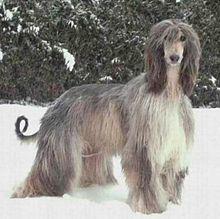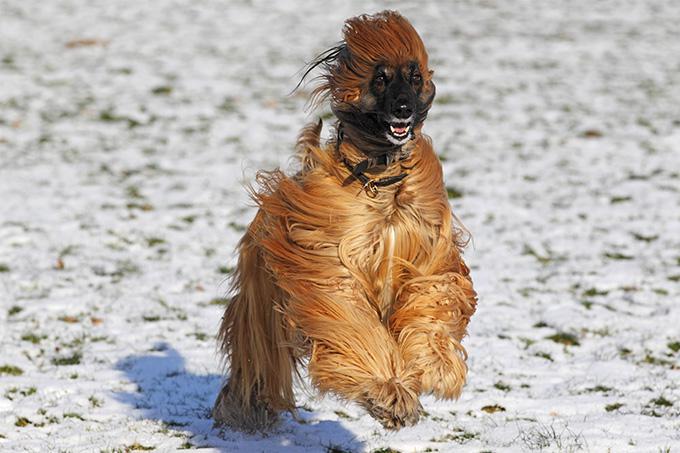The first image is the image on the left, the second image is the image on the right. Examine the images to the left and right. Is the description "There is a lone afghan hound in the center of each image." accurate? Answer yes or no. Yes. The first image is the image on the left, the second image is the image on the right. For the images shown, is this caption "The afghan hound in the left image is looking at the camera as the picture is taken." true? Answer yes or no. Yes. 